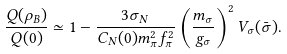<formula> <loc_0><loc_0><loc_500><loc_500>\frac { Q ( \rho _ { B } ) } { Q ( 0 ) } \simeq 1 - \frac { 3 \sigma _ { N } } { C _ { N } ( 0 ) m _ { \pi } ^ { 2 } f _ { \pi } ^ { 2 } } \left ( \frac { m _ { \sigma } } { g _ { \sigma } } \right ) ^ { 2 } V _ { \sigma } ( \bar { \sigma } ) .</formula> 